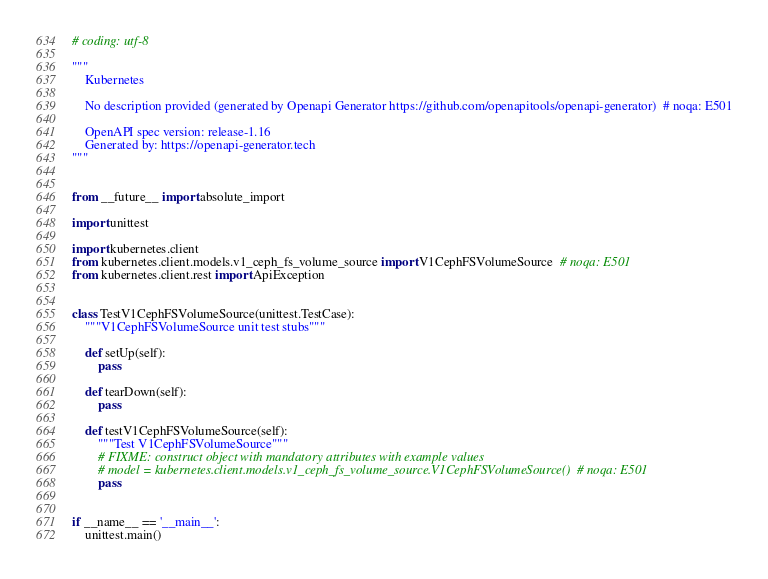Convert code to text. <code><loc_0><loc_0><loc_500><loc_500><_Python_># coding: utf-8

"""
    Kubernetes

    No description provided (generated by Openapi Generator https://github.com/openapitools/openapi-generator)  # noqa: E501

    OpenAPI spec version: release-1.16
    Generated by: https://openapi-generator.tech
"""


from __future__ import absolute_import

import unittest

import kubernetes.client
from kubernetes.client.models.v1_ceph_fs_volume_source import V1CephFSVolumeSource  # noqa: E501
from kubernetes.client.rest import ApiException


class TestV1CephFSVolumeSource(unittest.TestCase):
    """V1CephFSVolumeSource unit test stubs"""

    def setUp(self):
        pass

    def tearDown(self):
        pass

    def testV1CephFSVolumeSource(self):
        """Test V1CephFSVolumeSource"""
        # FIXME: construct object with mandatory attributes with example values
        # model = kubernetes.client.models.v1_ceph_fs_volume_source.V1CephFSVolumeSource()  # noqa: E501
        pass


if __name__ == '__main__':
    unittest.main()
</code> 